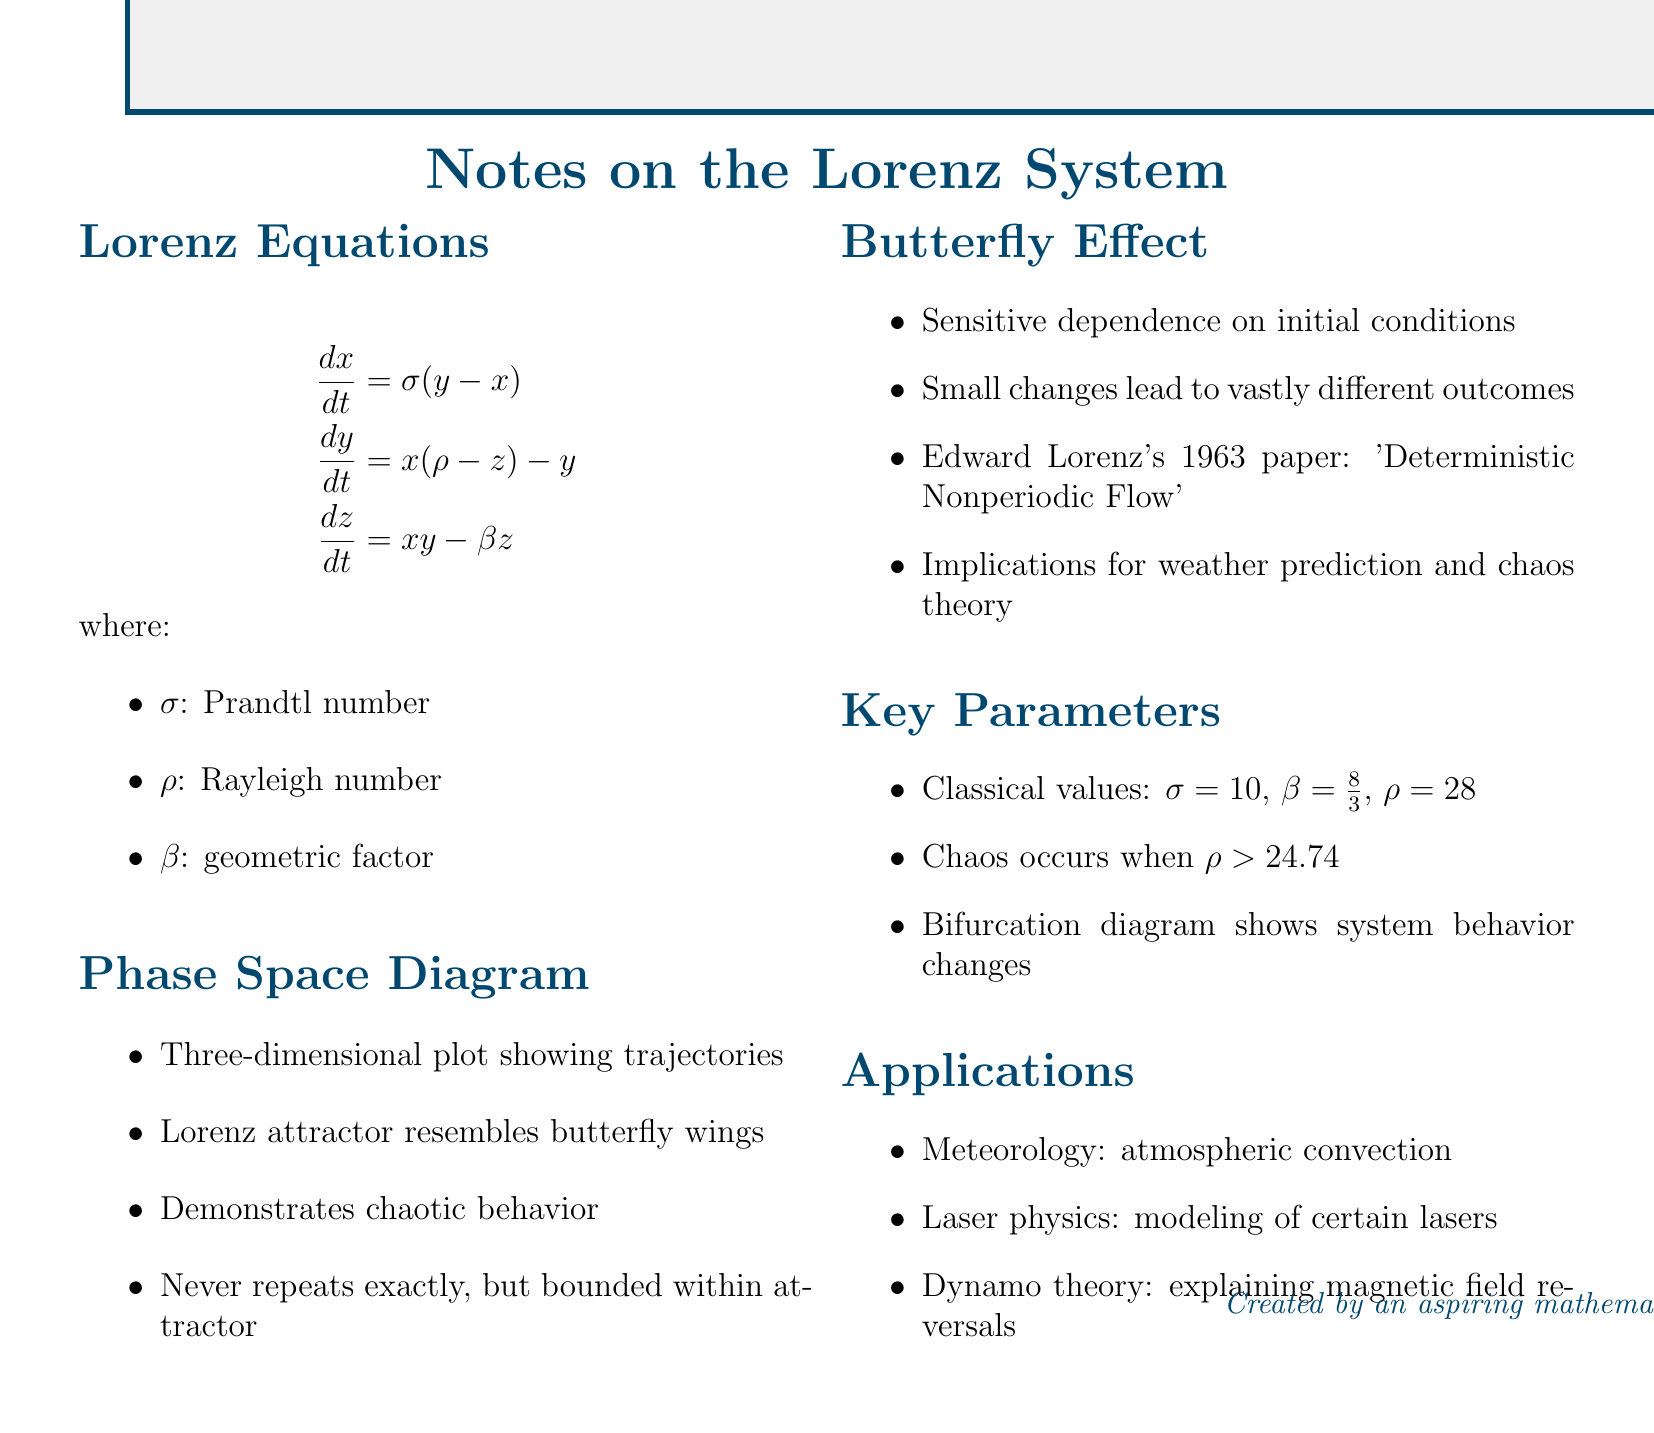What are the Lorenz equations? The Lorenz equations are a set of three differential equations that describe the behavior of a dynamical system.
Answer: dx/dt = σ(y - x), dy/dt = x(ρ - z) - y, dz/dt = xy - βz What is σ? σ is one of the key parameters in the Lorenz equations representing the Prandtl number.
Answer: Prandtl number What does the Lorenz attractor resemble? The Lorenz attractor has a specific shape that is compared to physical objects.
Answer: Butterfly wings What is the classical value of ρ? The document provides a classical value for the Rayleigh number denoted by ρ.
Answer: 28 What is the implication of chaos in the Lorenz system? The document describes a condition under which the chaos occurs in the system based on a parameter.
Answer: ρ > 24.74 Who wrote 'Deterministic Nonperiodic Flow'? The document cites a significant work related to the butterfly effect and the Lorenz system.
Answer: Edward Lorenz In what field is the Lorenz system applied according to the notes? The document lists various fields where the Lorenz system has applications.
Answer: Meteorology What does the three-dimensional plot demonstrate? The phase space diagram illustrates a fundamental characteristic of the Lorenz system.
Answer: Chaotic behavior What is a bifurcation diagram? The document mentions this as a tool to show changes in system behavior.
Answer: A diagram that shows system behavior changes What year was Lorenz's impactful paper published? The document states the year of the publication that introduced the butterfly effect.
Answer: 1963 